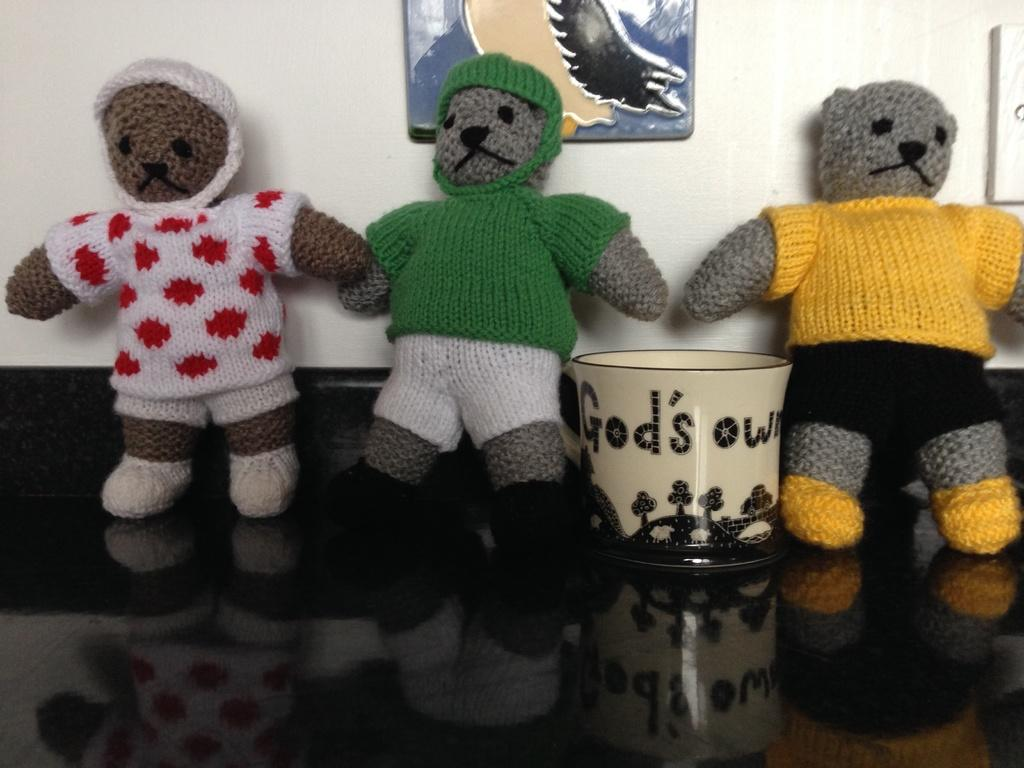What objects can be seen in the image? There are toys and a bowl in the image. Can you describe the location of the bowl? The bowl is in the image, but its exact location is not specified. What is visible in the background of the image? There is a frame on the wall in the background of the image. What type of paste is being used to stick the gold box to the wall in the image? There is no paste, gold, or box present in the image. 